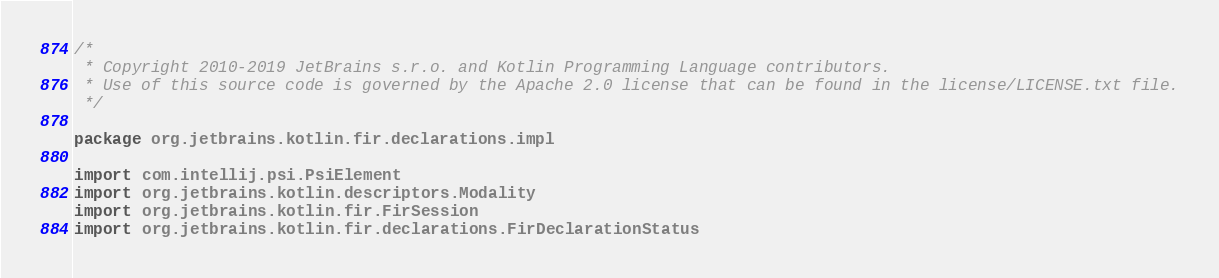Convert code to text. <code><loc_0><loc_0><loc_500><loc_500><_Kotlin_>/*
 * Copyright 2010-2019 JetBrains s.r.o. and Kotlin Programming Language contributors.
 * Use of this source code is governed by the Apache 2.0 license that can be found in the license/LICENSE.txt file.
 */

package org.jetbrains.kotlin.fir.declarations.impl

import com.intellij.psi.PsiElement
import org.jetbrains.kotlin.descriptors.Modality
import org.jetbrains.kotlin.fir.FirSession
import org.jetbrains.kotlin.fir.declarations.FirDeclarationStatus</code> 